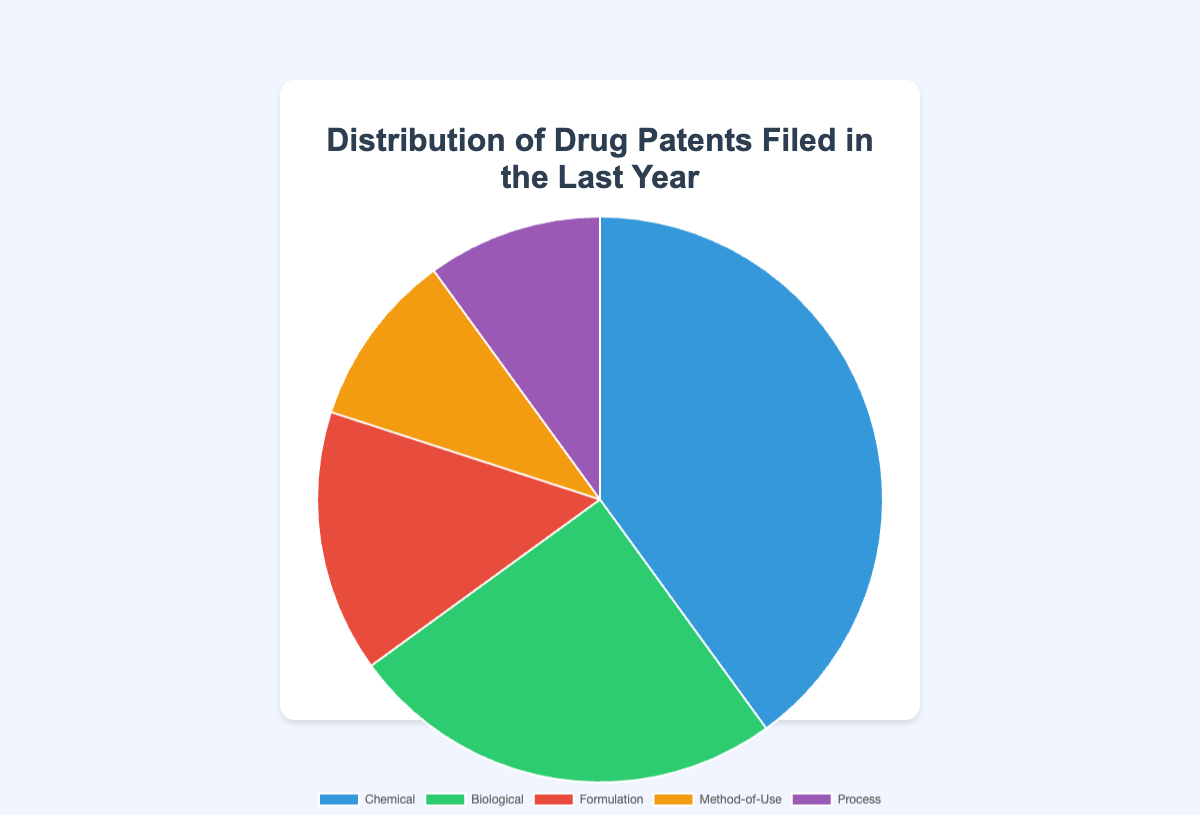What percentage of the patents filed are Method-of-Use and Process combined? Add the percentages for Method-of-Use (10%) and Process (10%): 10% + 10% = 20%.
Answer: 20% How does the number of Chemical patents compare to Biological patents? The percentage of Chemical patents (40%) is higher than the percentage of Biological patents (25%).
Answer: Chemical > Biological Which type of drug patent has the smallest share? The types of patents with the smallest shares are Method-of-Use and Process, each with 10%.
Answer: Method-of-Use and Process Are Formulation and Method-of-Use patents together more than the Biological patents? Sum the percentages of Formulation (15%) and Method-of-Use (10%): 15% + 10% = 25%. The combined percentage (25%) equals the percentage of Biological patents (25%).
Answer: No What is the difference in percentage between Chemical and Formulation patents? Subtract the percentage of Formulation patents (15%) from the percentage of Chemical patents (40%): 40% - 15% = 25%.
Answer: 25% Which type of drug patent is represented by the green section in the chart? Identify that the green section in the pie chart corresponds to Biological patents (25%).
Answer: Biological How many more times larger is the share of Chemical patents compared to Method-of-Use patents? Divide the percentage of Chemical patents (40%) by the percentage of Method-of-Use patents (10%): 40% / 10% = 4 times.
Answer: 4 times What is the average percentage share of all the types of drug patents filed? Sum the percentages of all types (40% + 25% + 15% + 10% + 10%) which is 100%, and divide by the number of types (5): 100% / 5 = 20%.
Answer: 20% If 200 drug patents were filed in total last year, how many of them were Process patents? Calculate 10% of 200: 200 * 0.10 = 20.
Answer: 20 